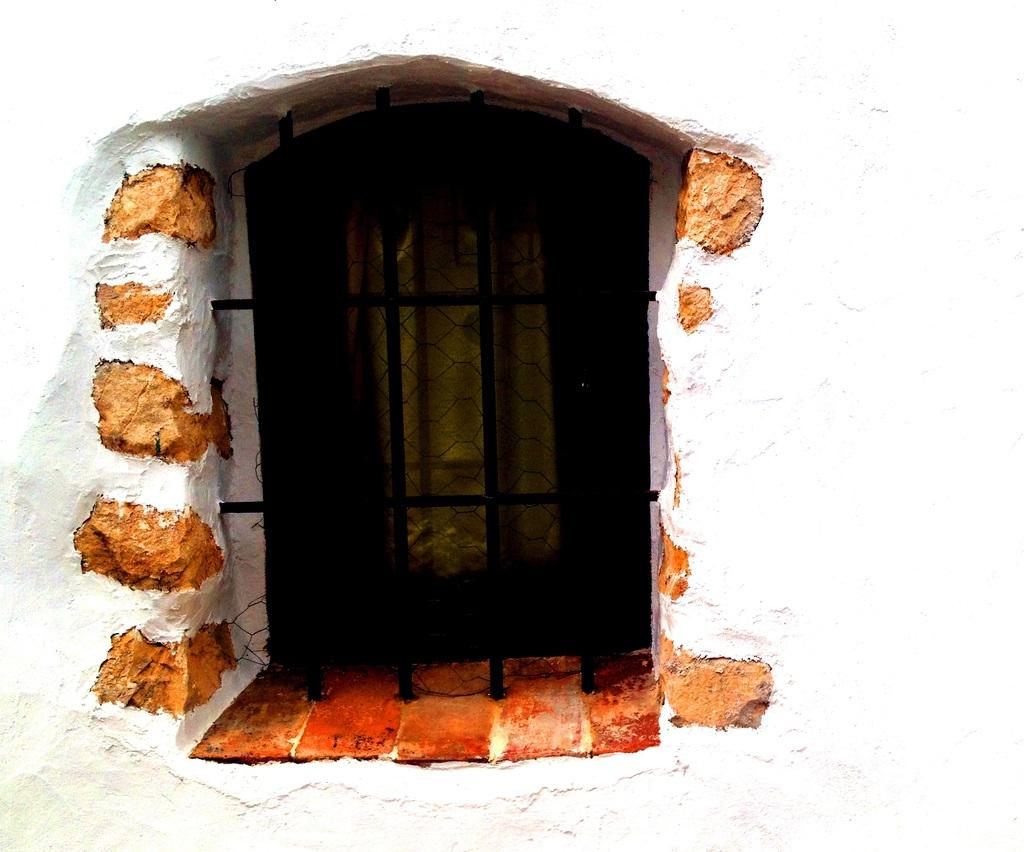What is the color of the wall in the image? The wall in the image is white. What feature is present on the wall? There is a window in the image. What type of beef can be seen grazing on the grass outside the window in the image? There is no beef or grass present in the image; it only features a white wall with a window. 